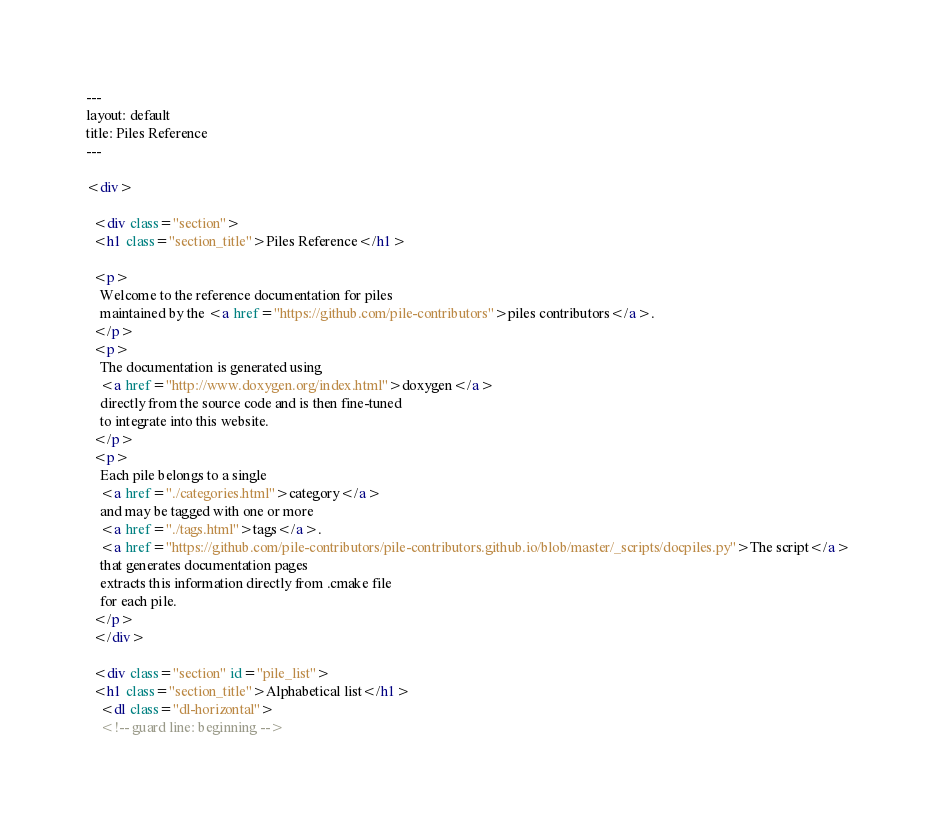<code> <loc_0><loc_0><loc_500><loc_500><_HTML_>---
layout: default
title: Piles Reference
---

<div>

  <div class="section">
  <h1 class="section_title">Piles Reference</h1>

  <p>
    Welcome to the reference documentation for piles 
    maintained by the <a href="https://github.com/pile-contributors">piles contributors</a>.
  </p>
  <p>
    The documentation is generated using 
    <a href="http://www.doxygen.org/index.html">doxygen</a>
    directly from the source code and is then fine-tuned
    to integrate into this website.
  </p>
  <p>
    Each pile belongs to a single 
    <a href="./categories.html">category</a>
    and may be tagged with one or more 
    <a href="./tags.html">tags</a>.
    <a href="https://github.com/pile-contributors/pile-contributors.github.io/blob/master/_scripts/docpiles.py">The script</a>
    that generates documentation pages
    extracts this information directly from .cmake file
    for each pile.
  </p>
  </div>

  <div class="section" id="pile_list">
  <h1 class="section_title">Alphabetical list</h1>
    <dl class="dl-horizontal">
    <!-- guard line: beginning --></code> 